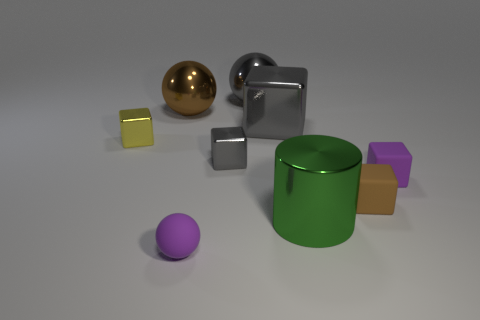What color is the big block that is the same material as the big brown object?
Give a very brief answer. Gray. Is the size of the purple rubber object that is right of the purple sphere the same as the sphere that is right of the small gray metallic object?
Make the answer very short. No. There is a large object that is both on the right side of the purple rubber sphere and behind the large cube; what shape is it?
Ensure brevity in your answer.  Sphere. Are there any tiny balls made of the same material as the green thing?
Your answer should be compact. No. There is a cube that is the same color as the small matte ball; what is it made of?
Offer a terse response. Rubber. Are the brown thing that is behind the yellow metal thing and the small object that is right of the small brown block made of the same material?
Your answer should be very brief. No. Is the number of large cyan cylinders greater than the number of big green metal cylinders?
Offer a terse response. No. There is a cylinder in front of the gray object to the right of the large ball right of the tiny gray block; what color is it?
Make the answer very short. Green. There is a tiny rubber object in front of the green metal cylinder; is it the same color as the rubber cube that is behind the tiny brown object?
Your response must be concise. Yes. There is a rubber thing on the left side of the gray shiny ball; how many shiny balls are behind it?
Keep it short and to the point. 2. 